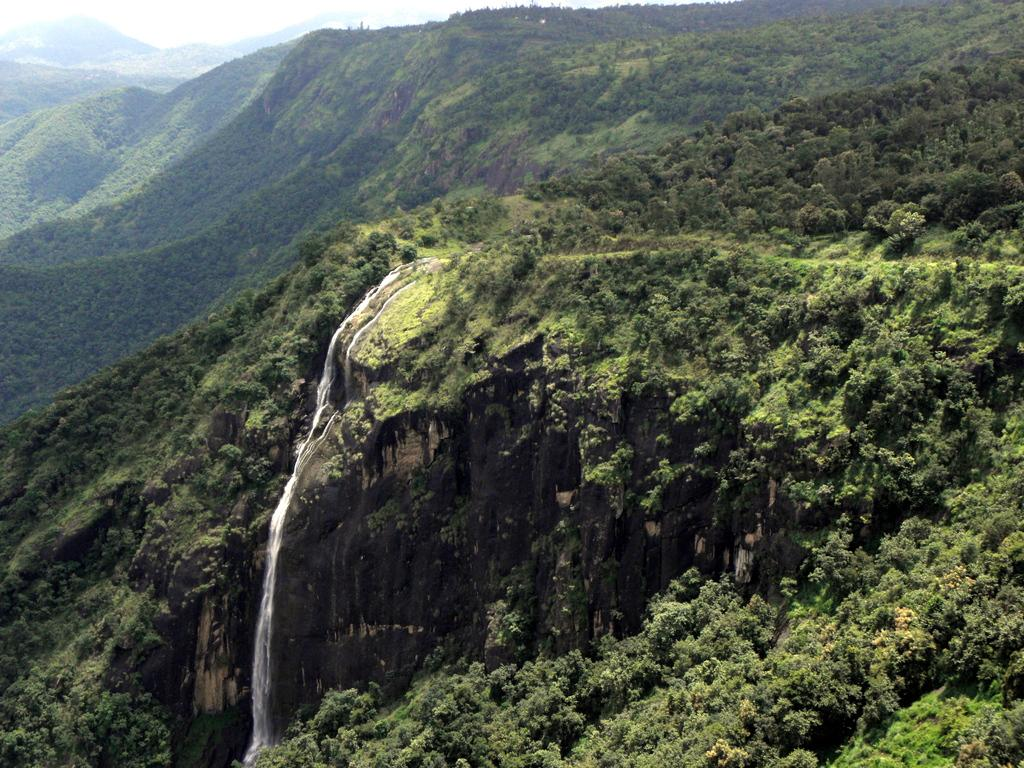What type of natural landform can be seen in the image? There are mountains in the image. What type of vegetation is present in the image? There are trees in the image. What type of water feature can be seen in the image? There is a waterfall in the image. What scent can be detected from the field in the image? There is no field present in the image, so it is not possible to detect a scent from it. 